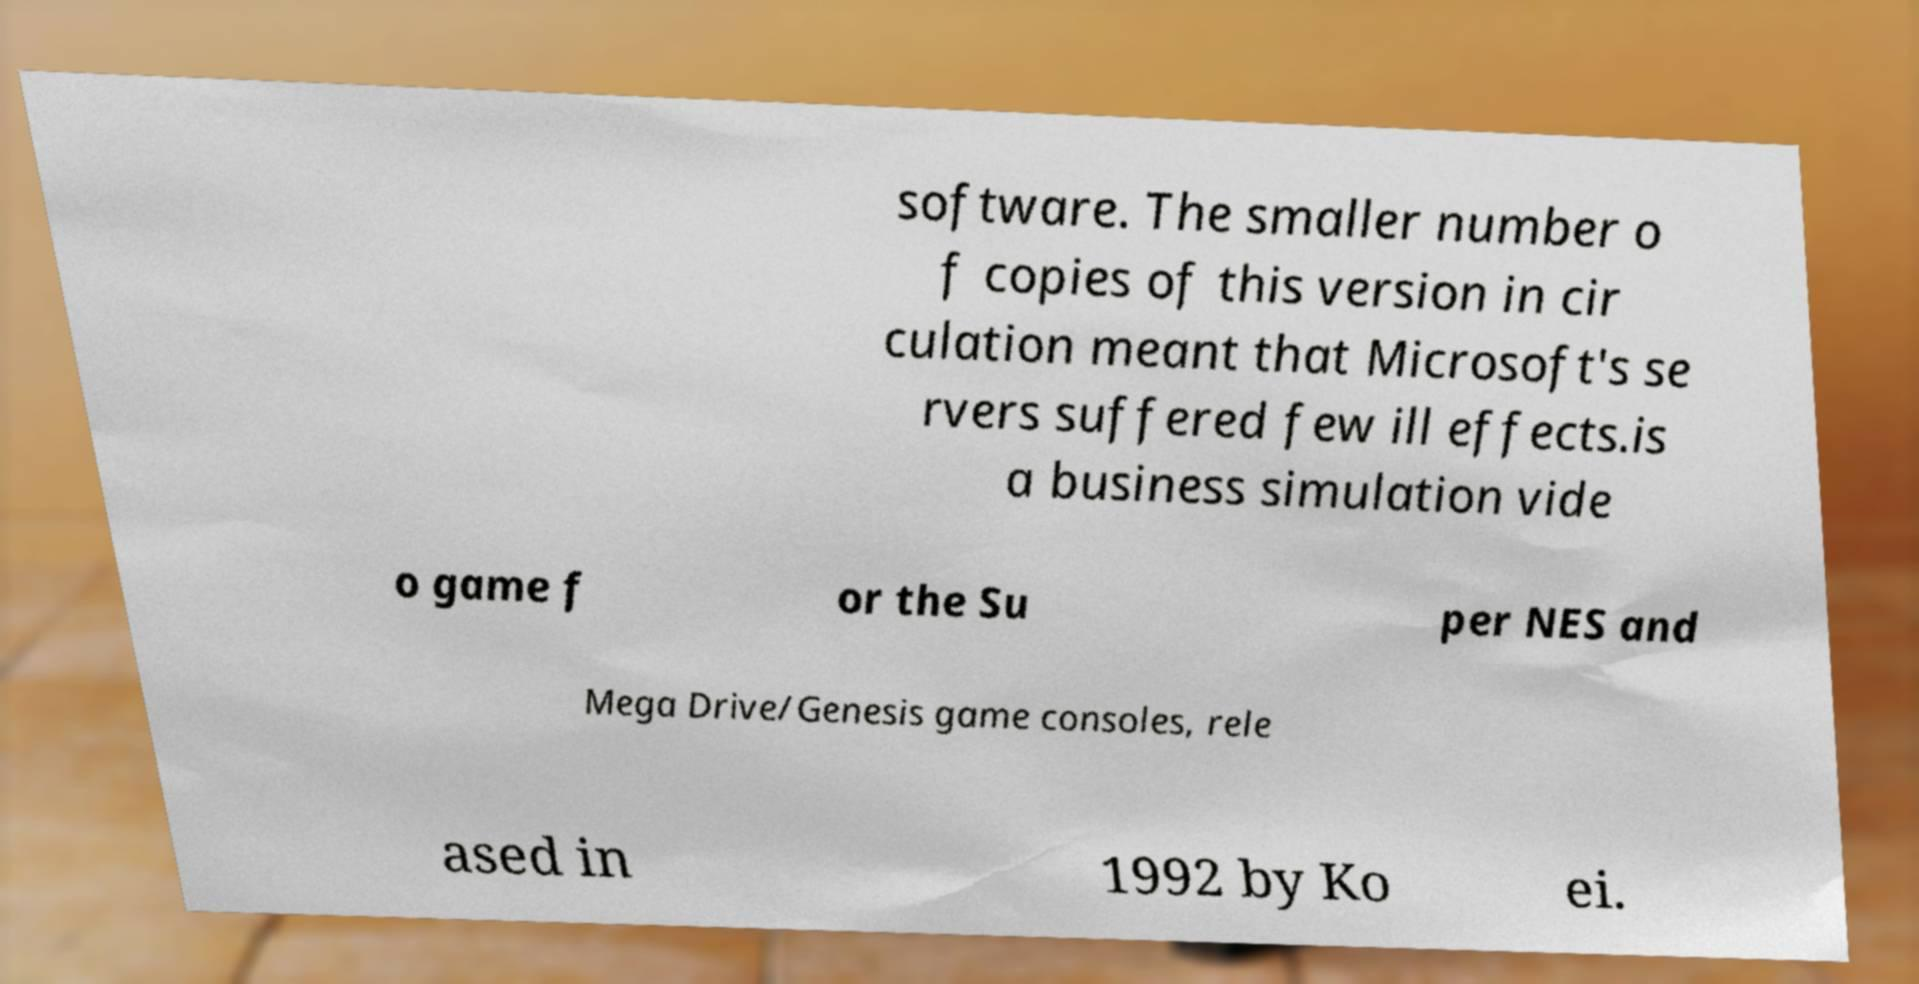Could you assist in decoding the text presented in this image and type it out clearly? software. The smaller number o f copies of this version in cir culation meant that Microsoft's se rvers suffered few ill effects.is a business simulation vide o game f or the Su per NES and Mega Drive/Genesis game consoles, rele ased in 1992 by Ko ei. 